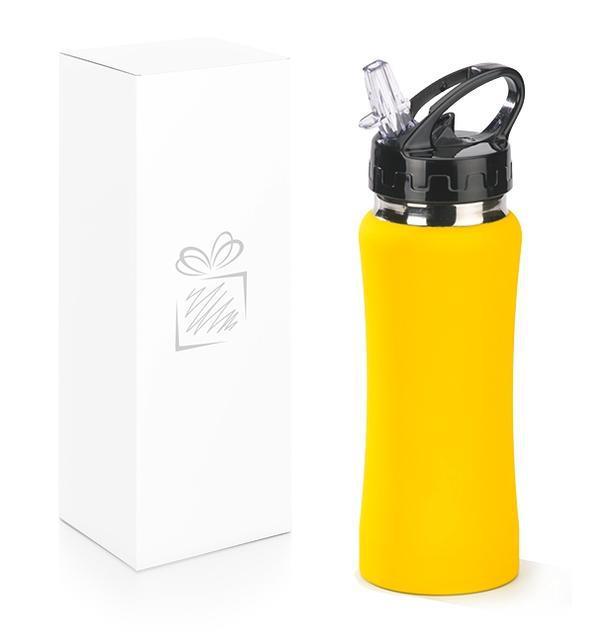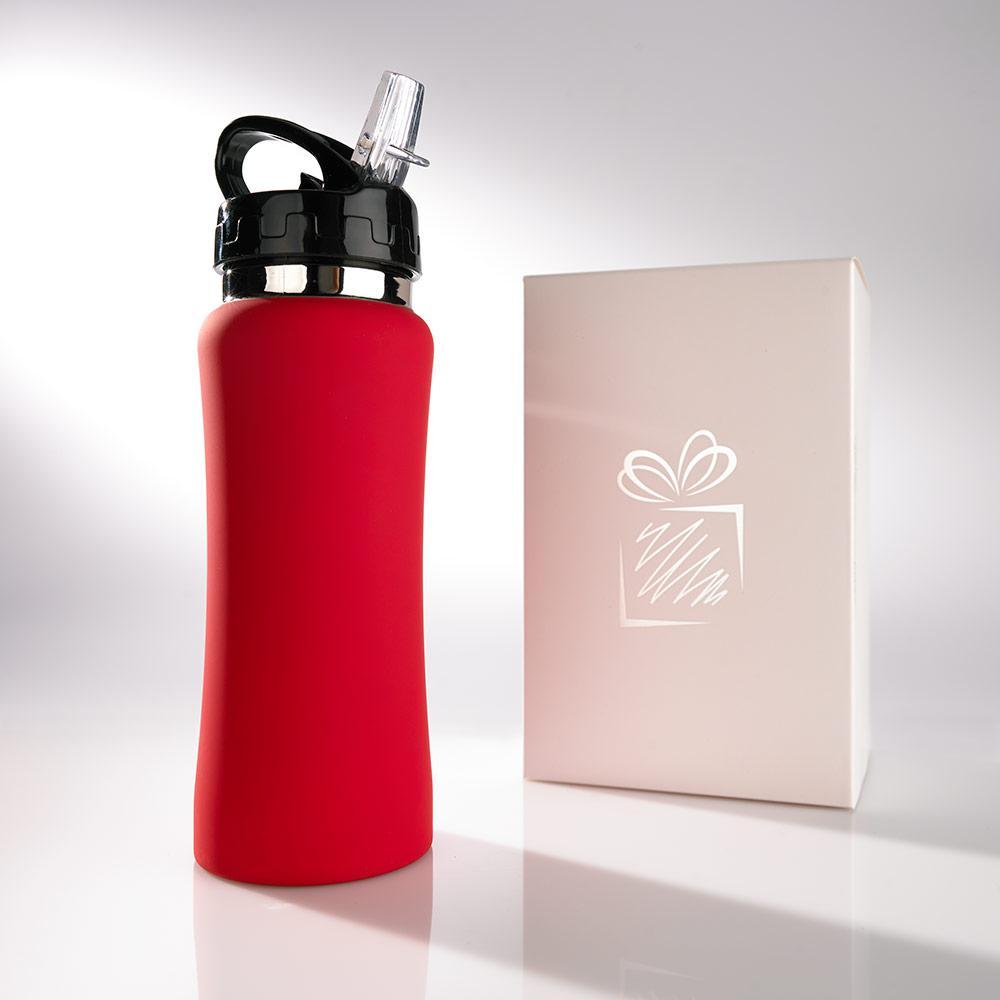The first image is the image on the left, the second image is the image on the right. For the images displayed, is the sentence "In at least one image there is a red bottle in front of a box with an engraved package on it." factually correct? Answer yes or no. Yes. 